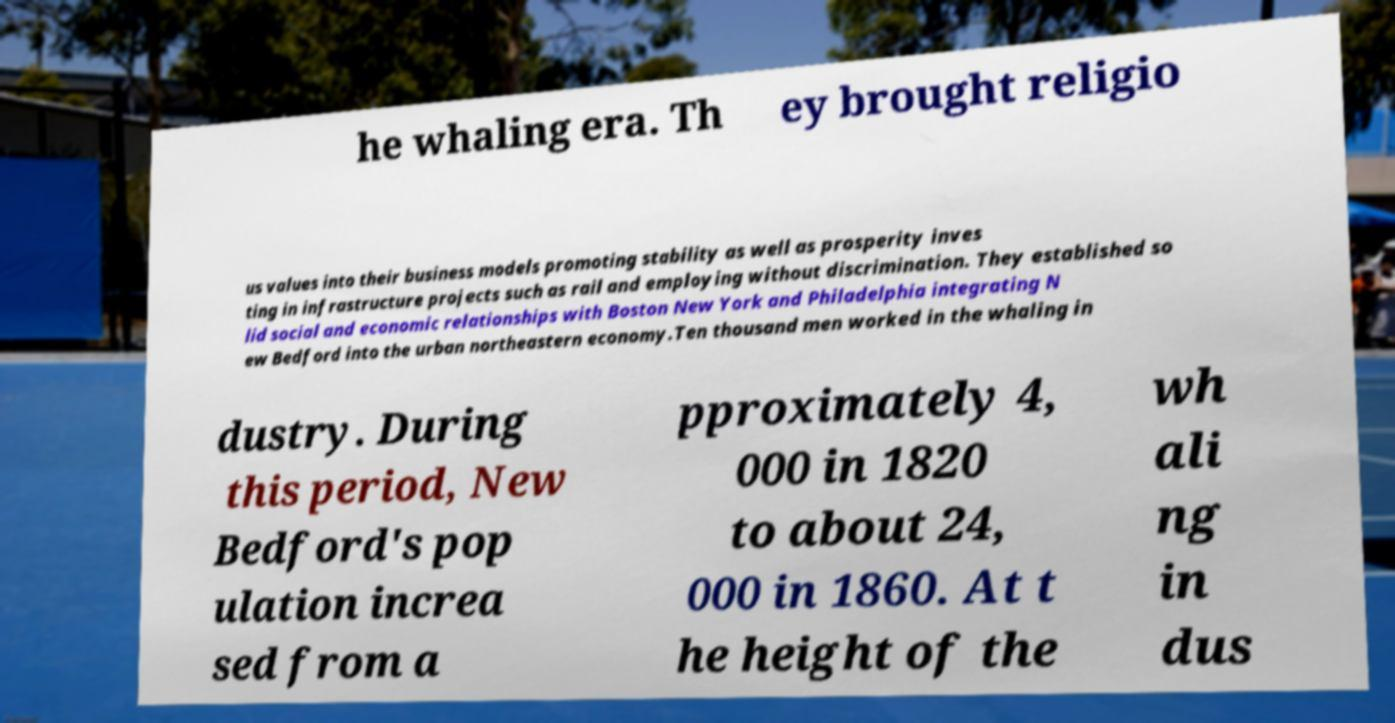Please read and relay the text visible in this image. What does it say? he whaling era. Th ey brought religio us values into their business models promoting stability as well as prosperity inves ting in infrastructure projects such as rail and employing without discrimination. They established so lid social and economic relationships with Boston New York and Philadelphia integrating N ew Bedford into the urban northeastern economy.Ten thousand men worked in the whaling in dustry. During this period, New Bedford's pop ulation increa sed from a pproximately 4, 000 in 1820 to about 24, 000 in 1860. At t he height of the wh ali ng in dus 